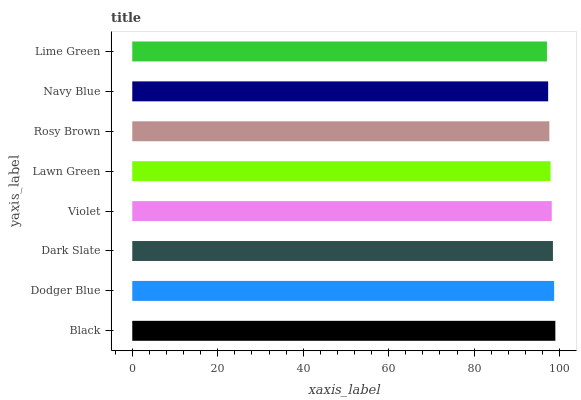Is Lime Green the minimum?
Answer yes or no. Yes. Is Black the maximum?
Answer yes or no. Yes. Is Dodger Blue the minimum?
Answer yes or no. No. Is Dodger Blue the maximum?
Answer yes or no. No. Is Black greater than Dodger Blue?
Answer yes or no. Yes. Is Dodger Blue less than Black?
Answer yes or no. Yes. Is Dodger Blue greater than Black?
Answer yes or no. No. Is Black less than Dodger Blue?
Answer yes or no. No. Is Violet the high median?
Answer yes or no. Yes. Is Lawn Green the low median?
Answer yes or no. Yes. Is Lime Green the high median?
Answer yes or no. No. Is Black the low median?
Answer yes or no. No. 